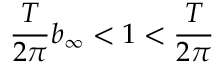Convert formula to latex. <formula><loc_0><loc_0><loc_500><loc_500>\frac { T } { 2 \pi } b _ { \infty } < 1 < \frac { T } { 2 \pi }</formula> 